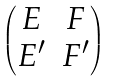Convert formula to latex. <formula><loc_0><loc_0><loc_500><loc_500>\begin{pmatrix} E & F \\ E ^ { \prime } & F ^ { \prime } \end{pmatrix}</formula> 